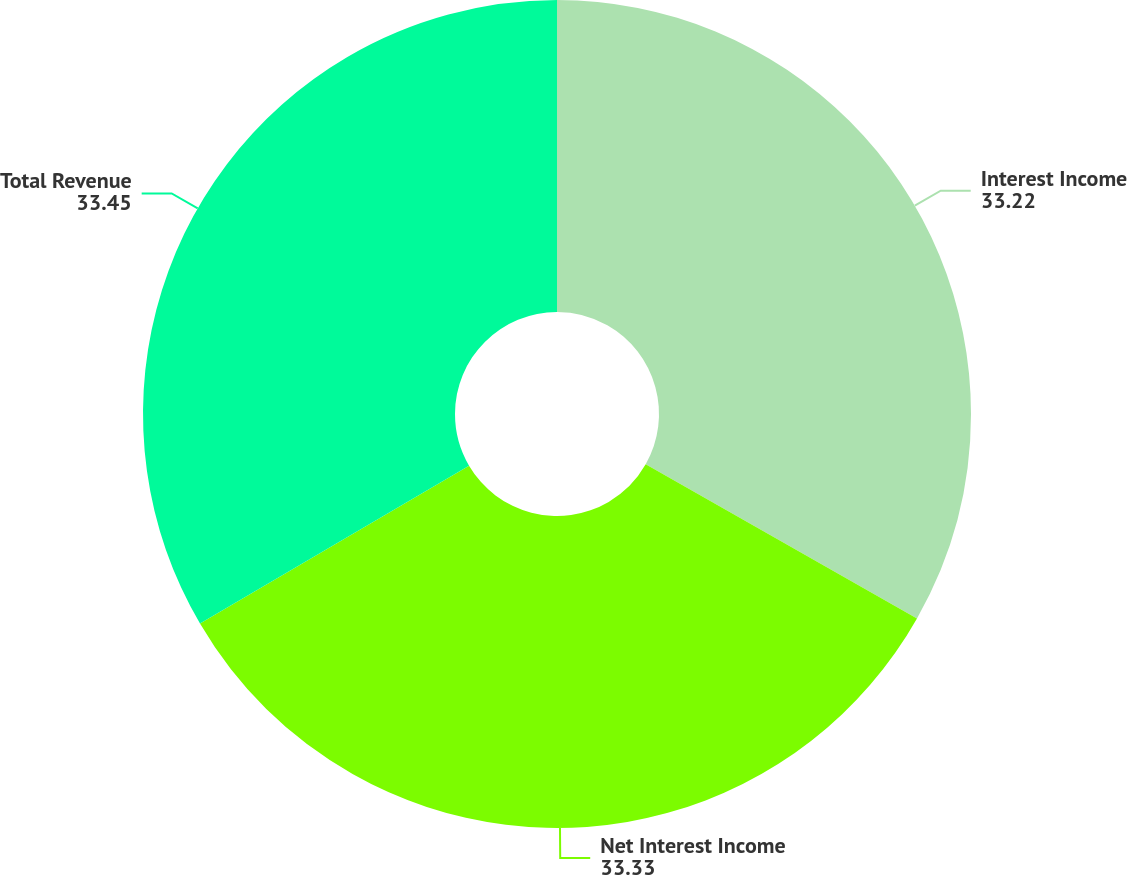<chart> <loc_0><loc_0><loc_500><loc_500><pie_chart><fcel>Interest Income<fcel>Net Interest Income<fcel>Total Revenue<nl><fcel>33.22%<fcel>33.33%<fcel>33.45%<nl></chart> 